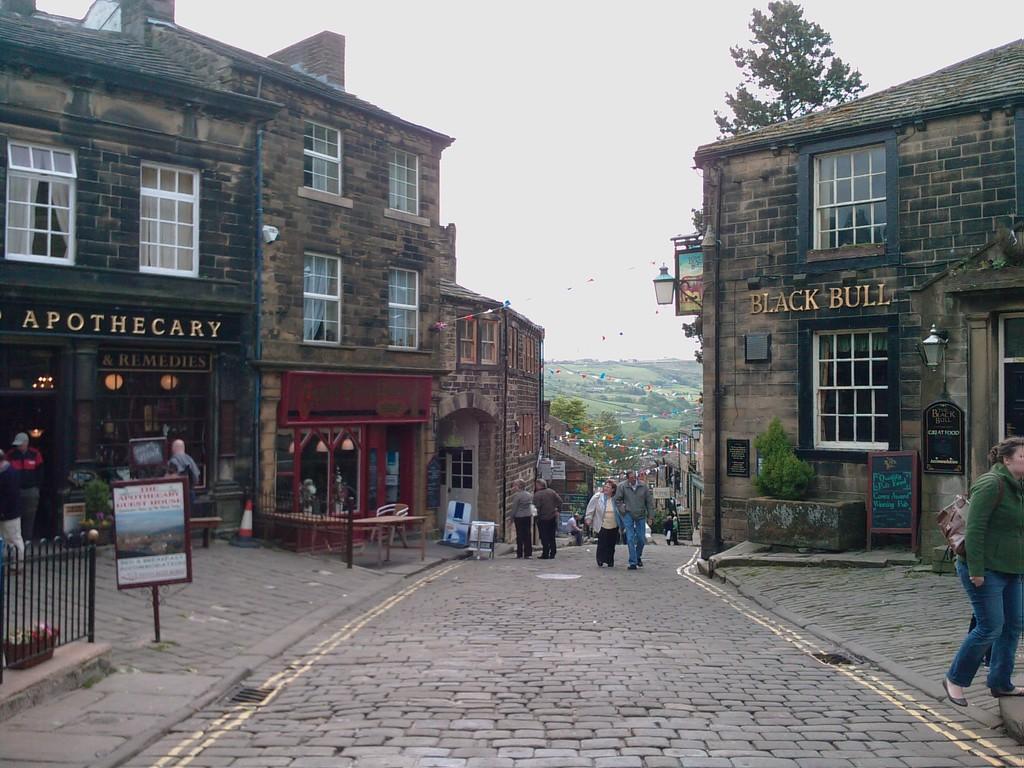In one or two sentences, can you explain what this image depicts? In this picture I can see group of people standing, there are boards, lights, there are buildings, there are decorative flags, there are trees, and in the background there is the sky. 